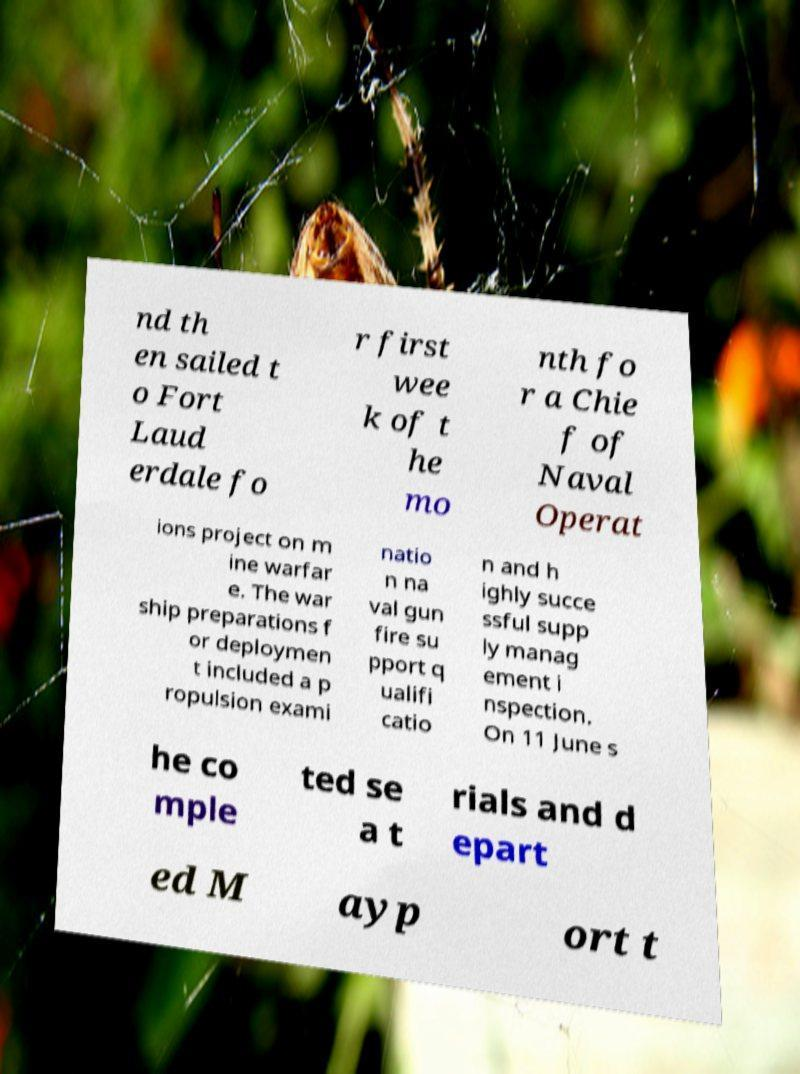Could you assist in decoding the text presented in this image and type it out clearly? nd th en sailed t o Fort Laud erdale fo r first wee k of t he mo nth fo r a Chie f of Naval Operat ions project on m ine warfar e. The war ship preparations f or deploymen t included a p ropulsion exami natio n na val gun fire su pport q ualifi catio n and h ighly succe ssful supp ly manag ement i nspection. On 11 June s he co mple ted se a t rials and d epart ed M ayp ort t 